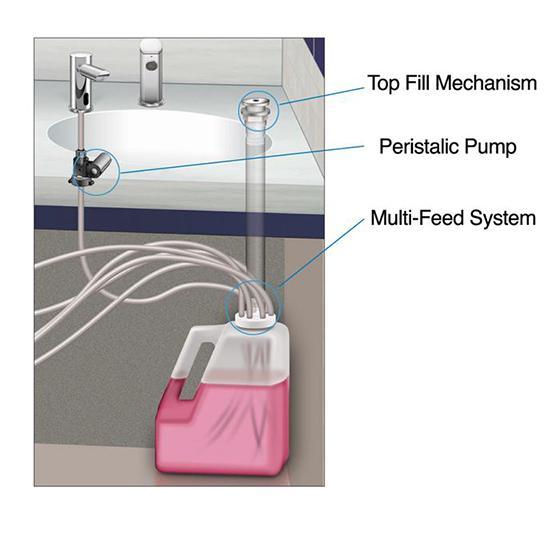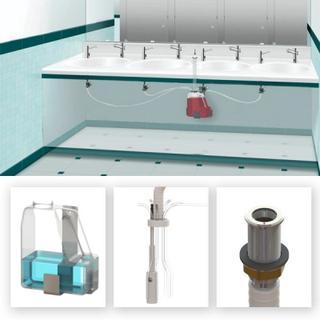The first image is the image on the left, the second image is the image on the right. Examine the images to the left and right. Is the description "An image shows exactly three side-by-side dispensers." accurate? Answer yes or no. No. 